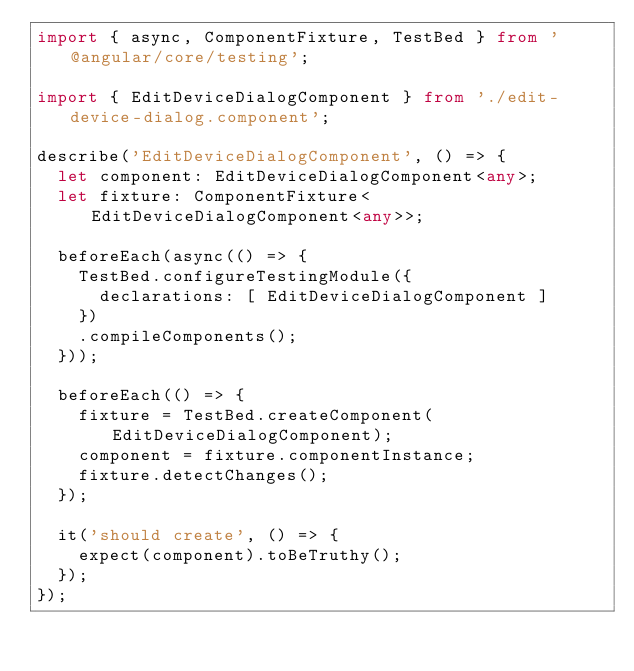<code> <loc_0><loc_0><loc_500><loc_500><_TypeScript_>import { async, ComponentFixture, TestBed } from '@angular/core/testing';

import { EditDeviceDialogComponent } from './edit-device-dialog.component';

describe('EditDeviceDialogComponent', () => {
  let component: EditDeviceDialogComponent<any>;
  let fixture: ComponentFixture<EditDeviceDialogComponent<any>>;

  beforeEach(async(() => {
    TestBed.configureTestingModule({
      declarations: [ EditDeviceDialogComponent ]
    })
    .compileComponents();
  }));

  beforeEach(() => {
    fixture = TestBed.createComponent(EditDeviceDialogComponent);
    component = fixture.componentInstance;
    fixture.detectChanges();
  });

  it('should create', () => {
    expect(component).toBeTruthy();
  });
});
</code> 